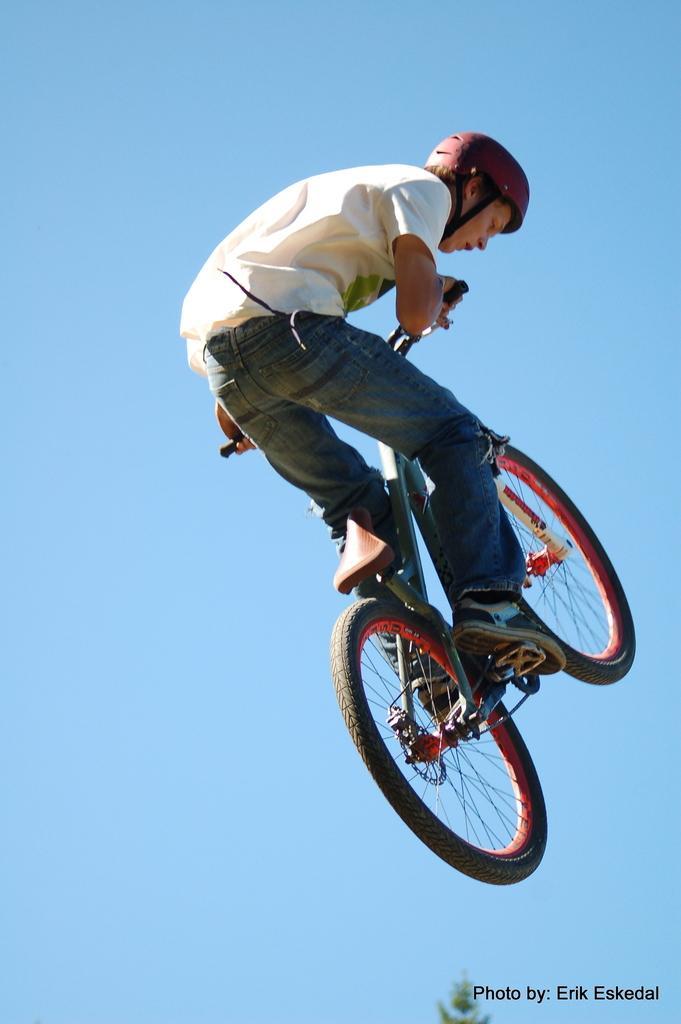Describe this image in one or two sentences. In this image In the middle there is a man he wear t shirt, trouser and shoes he is riding bicycle. In the background there is a sky. 